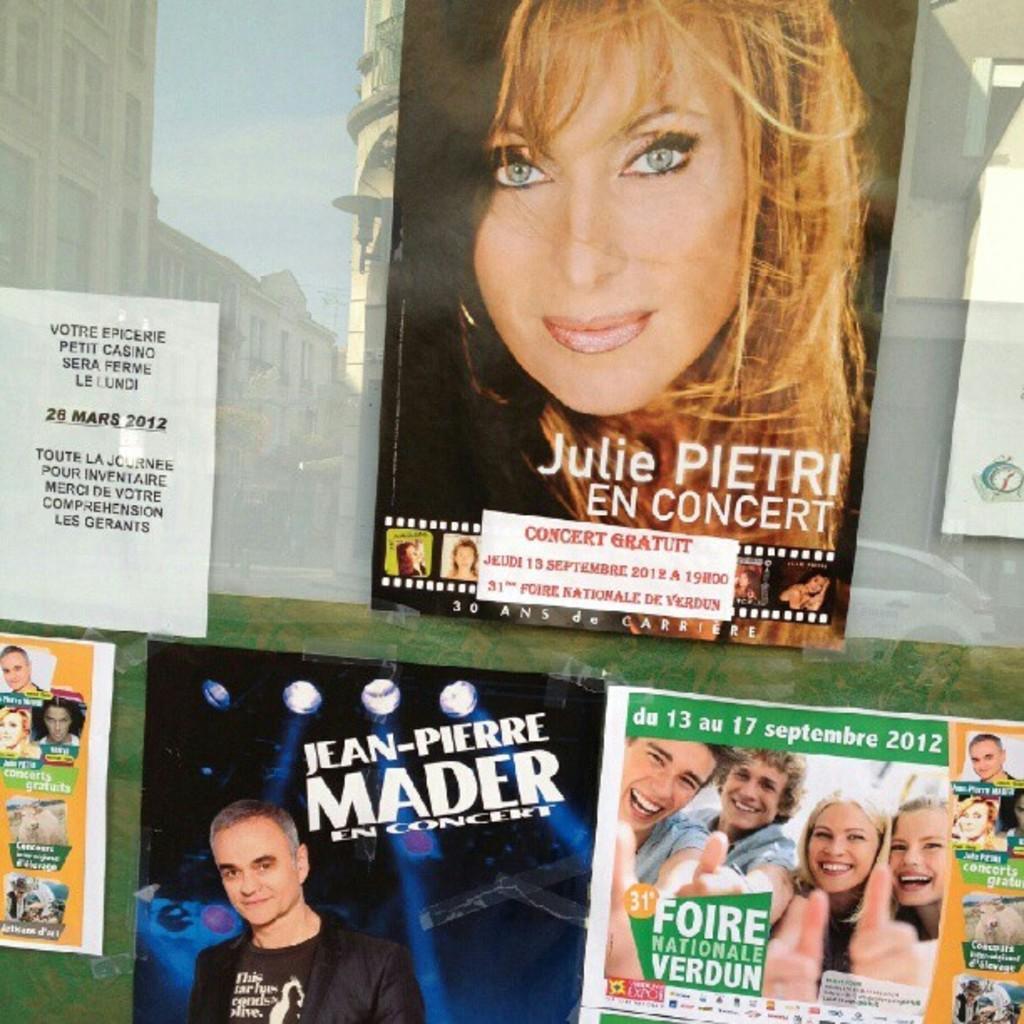How would you summarize this image in a sentence or two? This image consists of many poster on the glass of a building. And we can see the reflections of the buildings on this glass. 